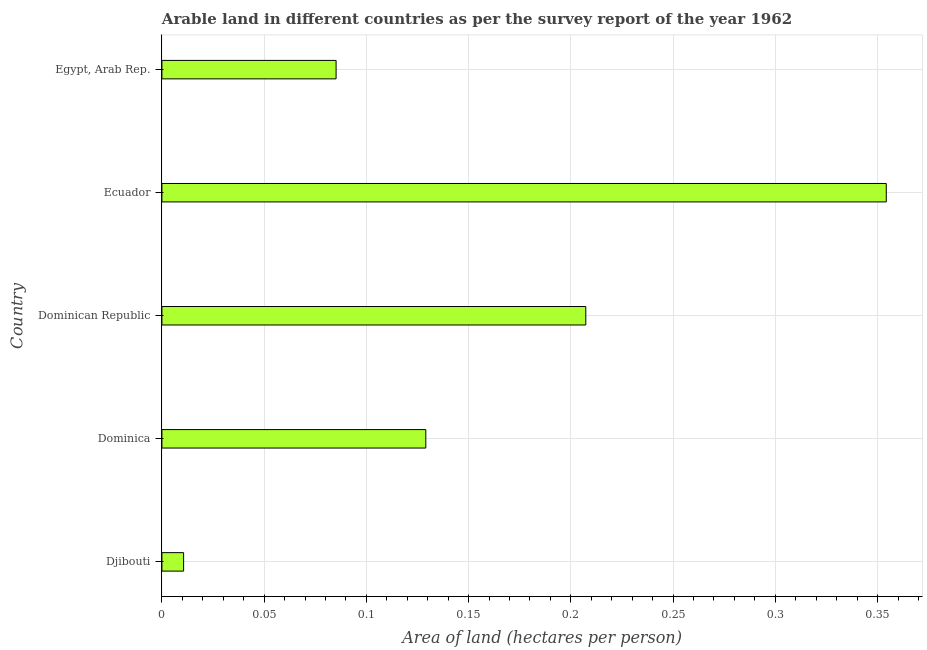Does the graph contain any zero values?
Give a very brief answer. No. What is the title of the graph?
Your answer should be very brief. Arable land in different countries as per the survey report of the year 1962. What is the label or title of the X-axis?
Offer a very short reply. Area of land (hectares per person). What is the label or title of the Y-axis?
Keep it short and to the point. Country. What is the area of arable land in Djibouti?
Offer a terse response. 0.01. Across all countries, what is the maximum area of arable land?
Provide a short and direct response. 0.35. Across all countries, what is the minimum area of arable land?
Give a very brief answer. 0.01. In which country was the area of arable land maximum?
Provide a short and direct response. Ecuador. In which country was the area of arable land minimum?
Give a very brief answer. Djibouti. What is the sum of the area of arable land?
Make the answer very short. 0.79. What is the difference between the area of arable land in Dominican Republic and Egypt, Arab Rep.?
Your answer should be compact. 0.12. What is the average area of arable land per country?
Ensure brevity in your answer.  0.16. What is the median area of arable land?
Your answer should be very brief. 0.13. In how many countries, is the area of arable land greater than 0.31 hectares per person?
Your response must be concise. 1. What is the ratio of the area of arable land in Dominican Republic to that in Ecuador?
Keep it short and to the point. 0.58. Is the area of arable land in Djibouti less than that in Dominica?
Provide a short and direct response. Yes. What is the difference between the highest and the second highest area of arable land?
Keep it short and to the point. 0.15. Is the sum of the area of arable land in Dominica and Egypt, Arab Rep. greater than the maximum area of arable land across all countries?
Make the answer very short. No. What is the difference between the highest and the lowest area of arable land?
Keep it short and to the point. 0.34. How many bars are there?
Provide a short and direct response. 5. Are all the bars in the graph horizontal?
Your response must be concise. Yes. What is the difference between two consecutive major ticks on the X-axis?
Make the answer very short. 0.05. What is the Area of land (hectares per person) in Djibouti?
Your response must be concise. 0.01. What is the Area of land (hectares per person) in Dominica?
Give a very brief answer. 0.13. What is the Area of land (hectares per person) in Dominican Republic?
Give a very brief answer. 0.21. What is the Area of land (hectares per person) of Ecuador?
Offer a very short reply. 0.35. What is the Area of land (hectares per person) of Egypt, Arab Rep.?
Your response must be concise. 0.09. What is the difference between the Area of land (hectares per person) in Djibouti and Dominica?
Your answer should be compact. -0.12. What is the difference between the Area of land (hectares per person) in Djibouti and Dominican Republic?
Provide a short and direct response. -0.2. What is the difference between the Area of land (hectares per person) in Djibouti and Ecuador?
Offer a very short reply. -0.34. What is the difference between the Area of land (hectares per person) in Djibouti and Egypt, Arab Rep.?
Your answer should be very brief. -0.07. What is the difference between the Area of land (hectares per person) in Dominica and Dominican Republic?
Give a very brief answer. -0.08. What is the difference between the Area of land (hectares per person) in Dominica and Ecuador?
Keep it short and to the point. -0.23. What is the difference between the Area of land (hectares per person) in Dominica and Egypt, Arab Rep.?
Make the answer very short. 0.04. What is the difference between the Area of land (hectares per person) in Dominican Republic and Ecuador?
Make the answer very short. -0.15. What is the difference between the Area of land (hectares per person) in Dominican Republic and Egypt, Arab Rep.?
Ensure brevity in your answer.  0.12. What is the difference between the Area of land (hectares per person) in Ecuador and Egypt, Arab Rep.?
Keep it short and to the point. 0.27. What is the ratio of the Area of land (hectares per person) in Djibouti to that in Dominica?
Provide a short and direct response. 0.08. What is the ratio of the Area of land (hectares per person) in Djibouti to that in Dominican Republic?
Provide a succinct answer. 0.05. What is the ratio of the Area of land (hectares per person) in Djibouti to that in Ecuador?
Provide a succinct answer. 0.03. What is the ratio of the Area of land (hectares per person) in Dominica to that in Dominican Republic?
Ensure brevity in your answer.  0.62. What is the ratio of the Area of land (hectares per person) in Dominica to that in Ecuador?
Provide a succinct answer. 0.36. What is the ratio of the Area of land (hectares per person) in Dominica to that in Egypt, Arab Rep.?
Keep it short and to the point. 1.51. What is the ratio of the Area of land (hectares per person) in Dominican Republic to that in Ecuador?
Give a very brief answer. 0.58. What is the ratio of the Area of land (hectares per person) in Dominican Republic to that in Egypt, Arab Rep.?
Make the answer very short. 2.43. What is the ratio of the Area of land (hectares per person) in Ecuador to that in Egypt, Arab Rep.?
Give a very brief answer. 4.16. 